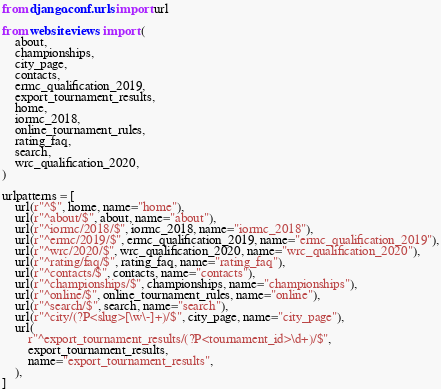<code> <loc_0><loc_0><loc_500><loc_500><_Python_>from django.conf.urls import url

from website.views import (
    about,
    championships,
    city_page,
    contacts,
    ermc_qualification_2019,
    export_tournament_results,
    home,
    iormc_2018,
    online_tournament_rules,
    rating_faq,
    search,
    wrc_qualification_2020,
)

urlpatterns = [
    url(r"^$", home, name="home"),
    url(r"^about/$", about, name="about"),
    url(r"^iormc/2018/$", iormc_2018, name="iormc_2018"),
    url(r"^ermc/2019/$", ermc_qualification_2019, name="ermc_qualification_2019"),
    url(r"^wrc/2020/$", wrc_qualification_2020, name="wrc_qualification_2020"),
    url(r"^rating/faq/$", rating_faq, name="rating_faq"),
    url(r"^contacts/$", contacts, name="contacts"),
    url(r"^championships/$", championships, name="championships"),
    url(r"^online/$", online_tournament_rules, name="online"),
    url(r"^search/$", search, name="search"),
    url(r"^city/(?P<slug>[\w\-]+)/$", city_page, name="city_page"),
    url(
        r"^export_tournament_results/(?P<tournament_id>\d+)/$",
        export_tournament_results,
        name="export_tournament_results",
    ),
]
</code> 